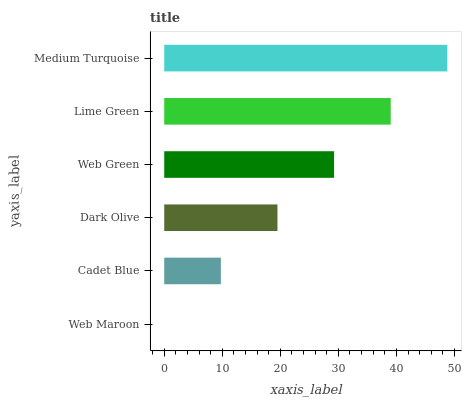Is Web Maroon the minimum?
Answer yes or no. Yes. Is Medium Turquoise the maximum?
Answer yes or no. Yes. Is Cadet Blue the minimum?
Answer yes or no. No. Is Cadet Blue the maximum?
Answer yes or no. No. Is Cadet Blue greater than Web Maroon?
Answer yes or no. Yes. Is Web Maroon less than Cadet Blue?
Answer yes or no. Yes. Is Web Maroon greater than Cadet Blue?
Answer yes or no. No. Is Cadet Blue less than Web Maroon?
Answer yes or no. No. Is Web Green the high median?
Answer yes or no. Yes. Is Dark Olive the low median?
Answer yes or no. Yes. Is Lime Green the high median?
Answer yes or no. No. Is Web Green the low median?
Answer yes or no. No. 